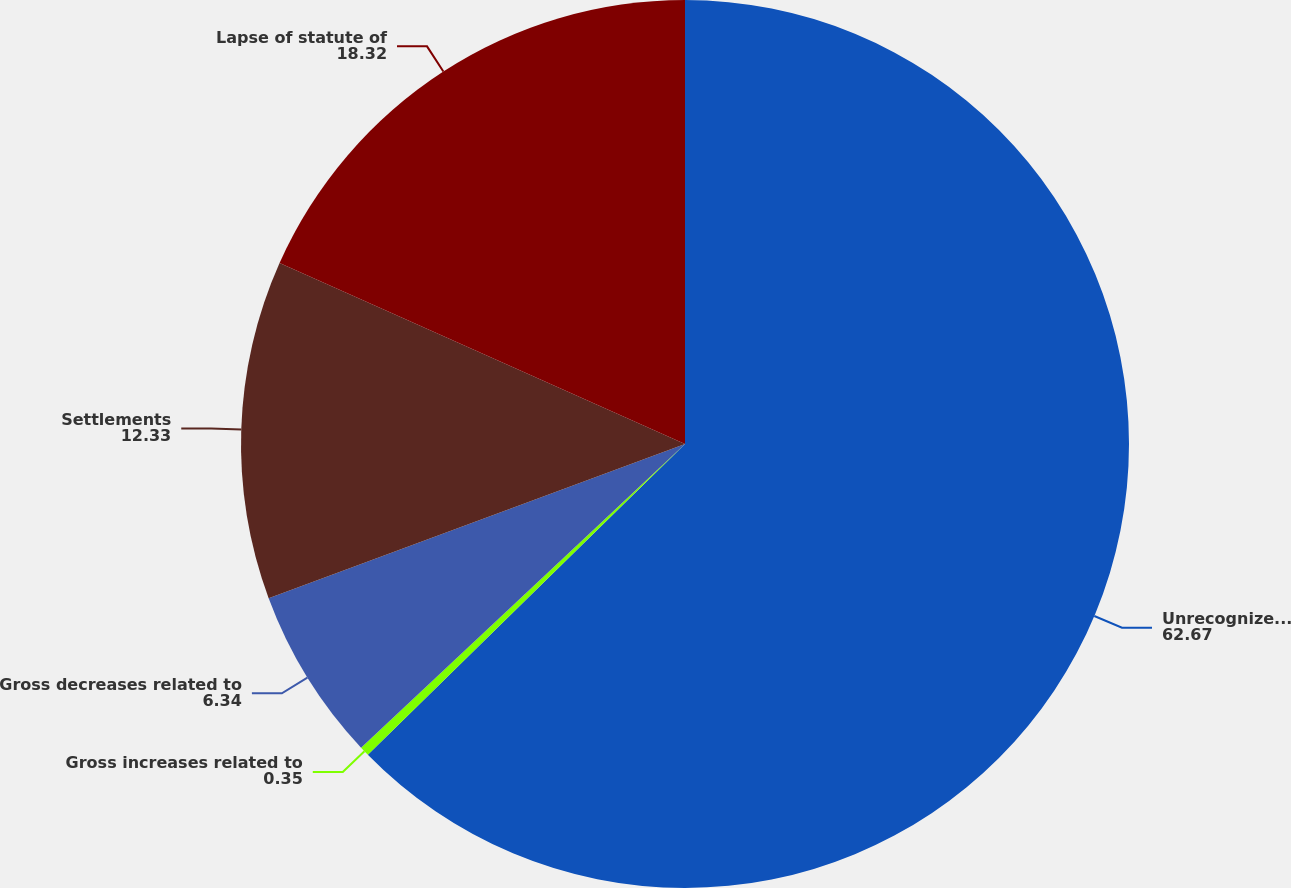Convert chart to OTSL. <chart><loc_0><loc_0><loc_500><loc_500><pie_chart><fcel>Unrecognized tax benefit<fcel>Gross increases related to<fcel>Gross decreases related to<fcel>Settlements<fcel>Lapse of statute of<nl><fcel>62.67%<fcel>0.35%<fcel>6.34%<fcel>12.33%<fcel>18.32%<nl></chart> 